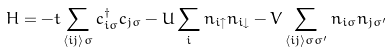Convert formula to latex. <formula><loc_0><loc_0><loc_500><loc_500>H = - t \sum _ { \langle i j \rangle \sigma } c ^ { \dagger } _ { i \sigma } c _ { j \sigma } - U \sum _ { i } n _ { i \uparrow } n _ { i \downarrow } - V \sum _ { \langle i j \rangle \sigma \sigma ^ { \prime } } n _ { i \sigma } n _ { j \sigma ^ { \prime } }</formula> 